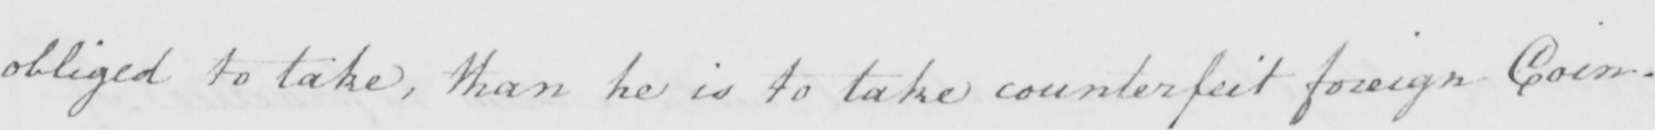Transcribe the text shown in this historical manuscript line. obliged to take , than he is to take counterfeit foreign Coin . 